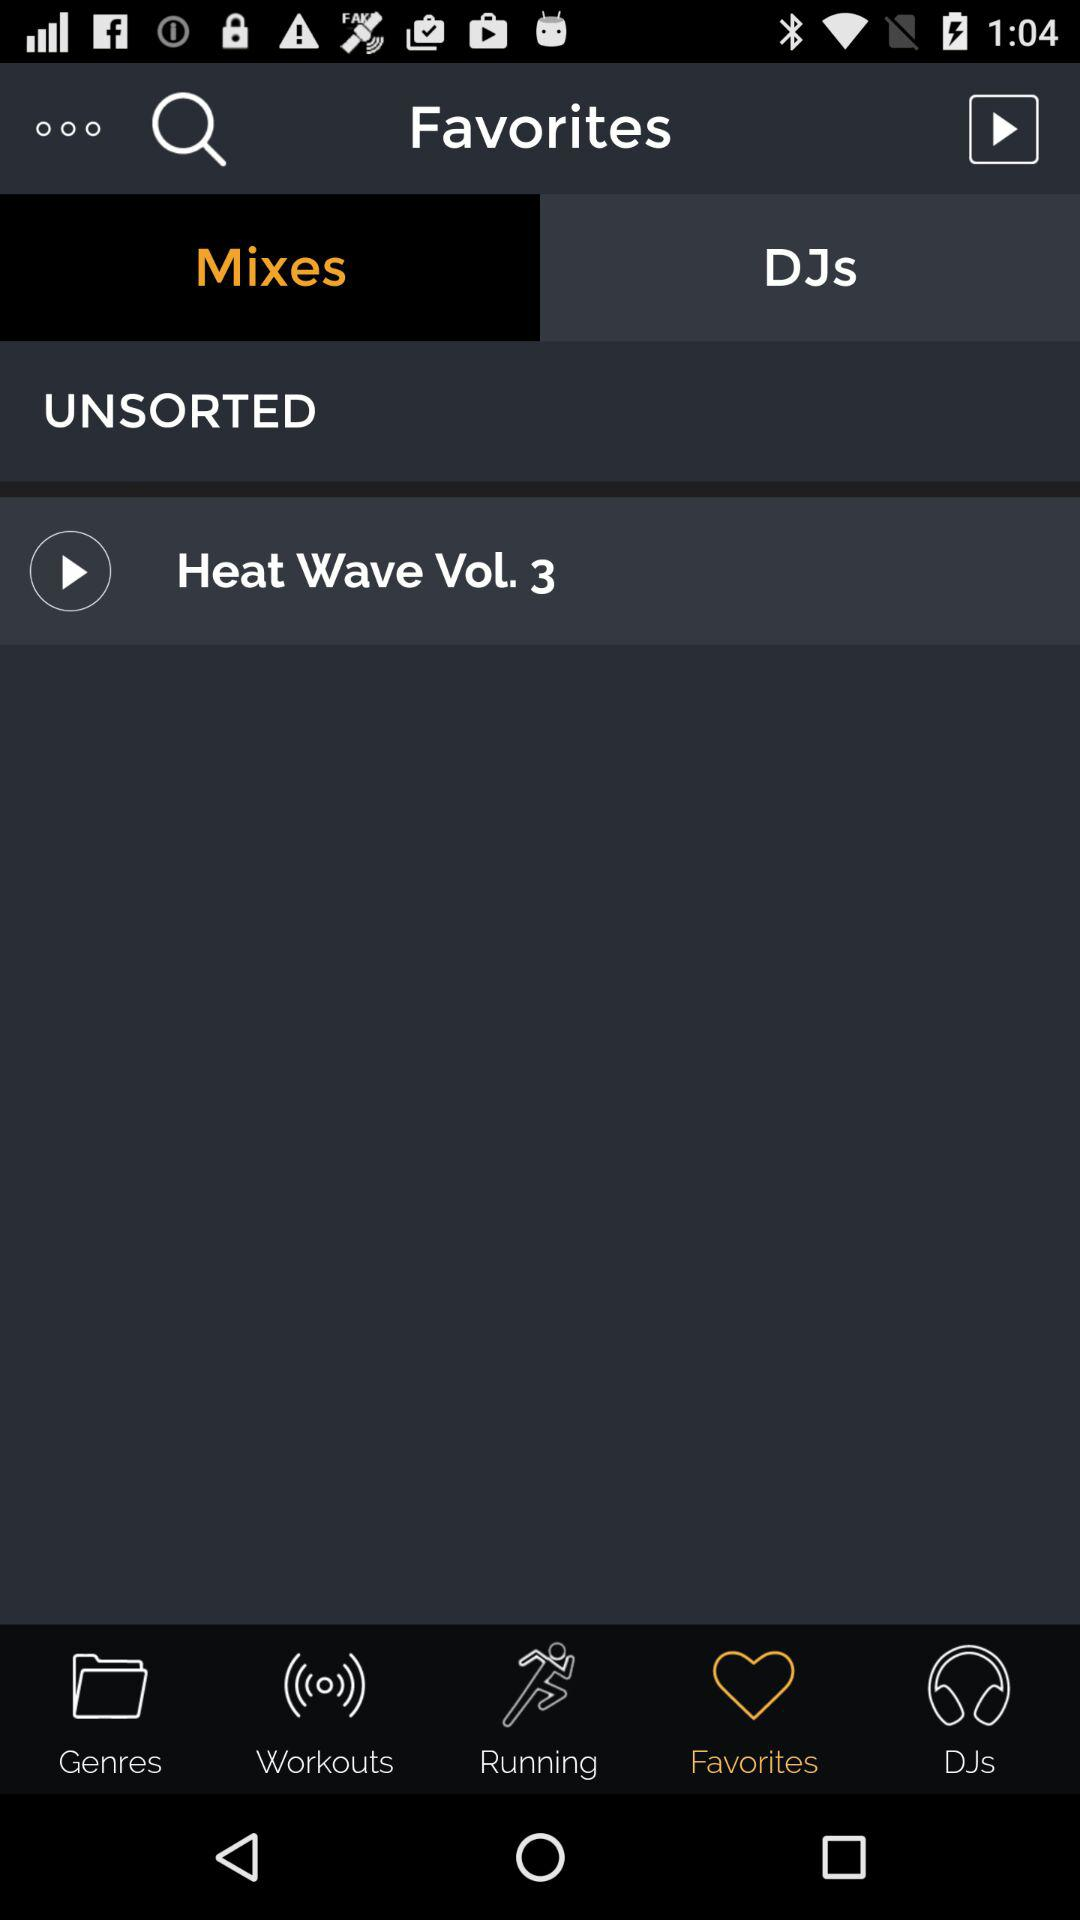Which tab has been selected? The selected tabs are "Favorites" and "Mixes". 